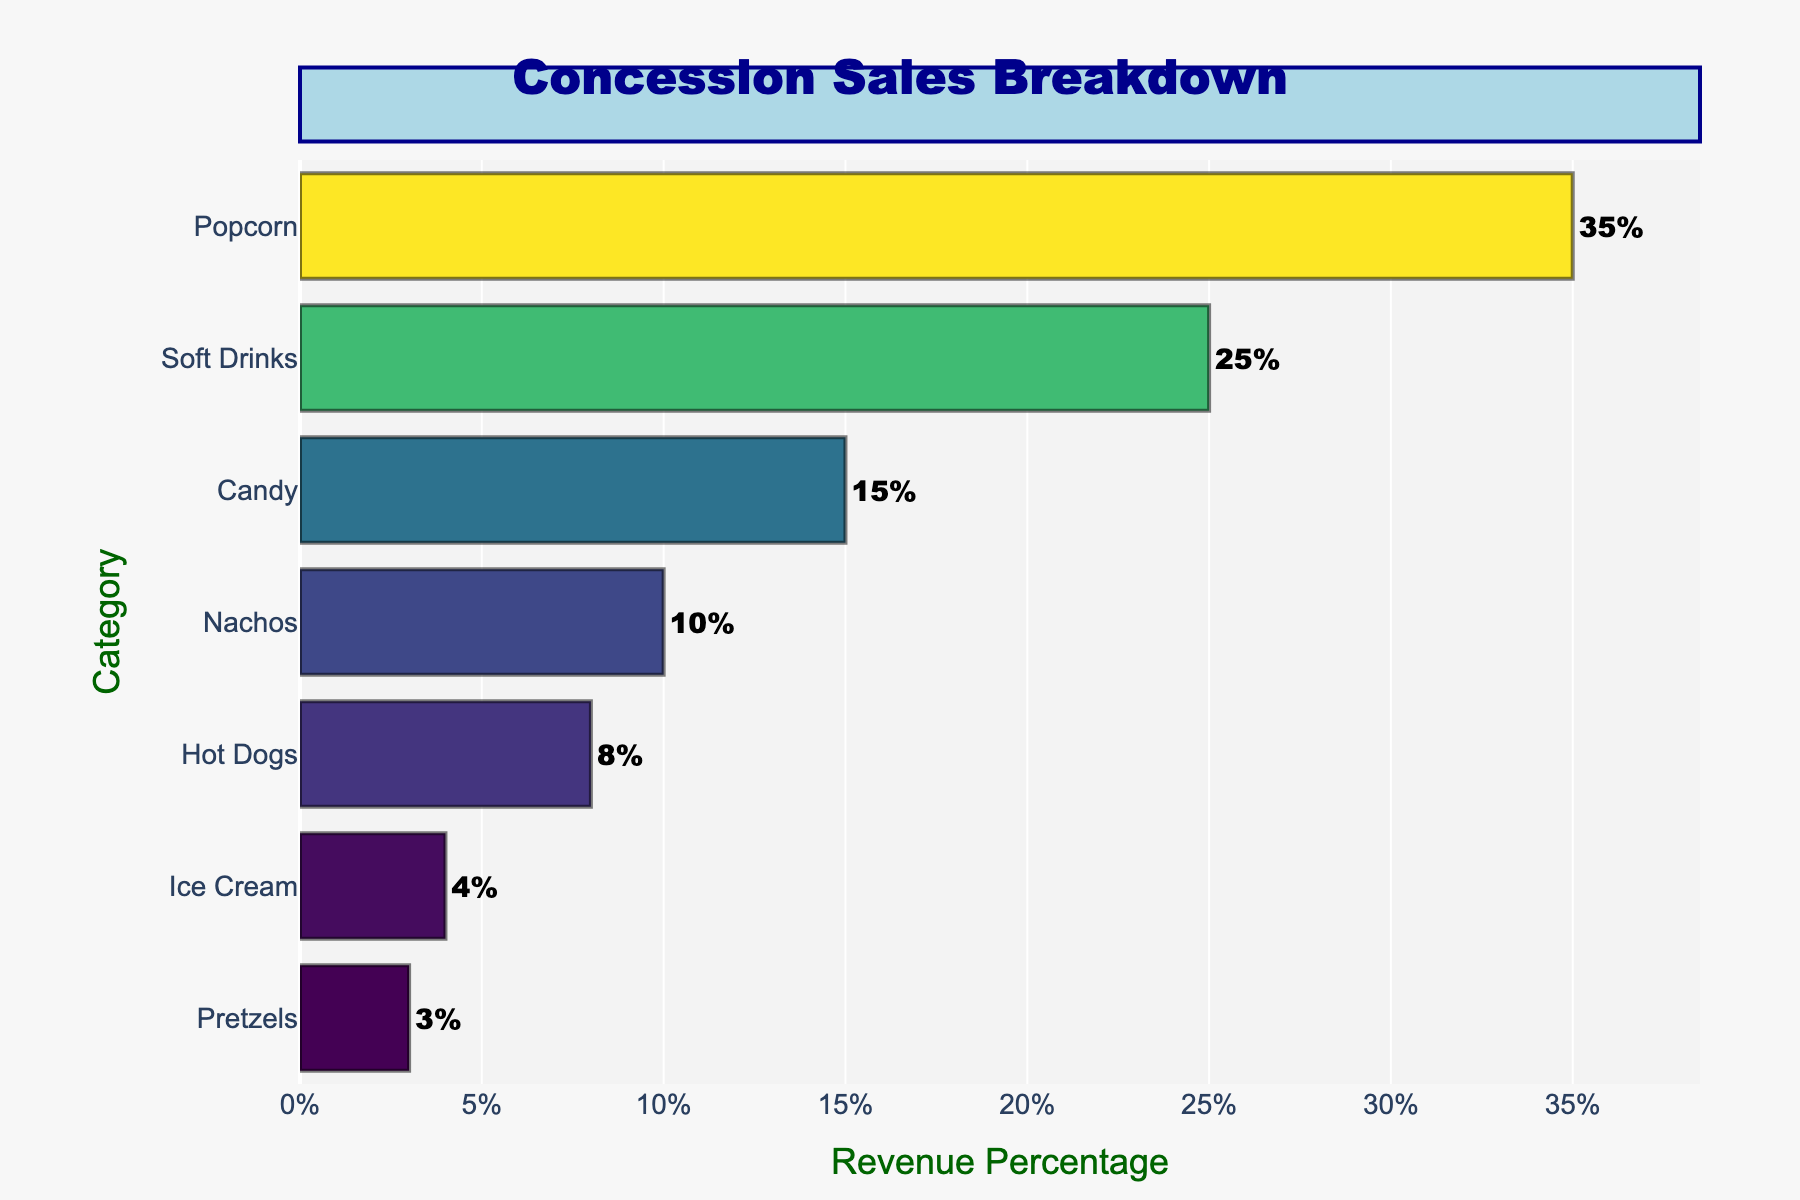What is the highest revenue percentage item in the concession sales breakdown? The horizontal bar chart shows different item categories with their respective revenue percentages. The item with the longest bar is "Popcorn" with a 35% revenue percentage.
Answer: Popcorn Which item category contributes the least to the concession sales revenue? The bar chart displays the categories with their revenue percentages. The shortest bar belongs to "Pretzels," which indicates a 3% revenue percentage.
Answer: Pretzels What is the combined revenue percentage of Soft Drinks and Candy? By looking at the chart, Soft Drinks have a 25% revenue and Candy has 15%. Adding these two percentages together gives the combined revenue percentage. 25% + 15% = 40%
Answer: 40% How much more revenue percentage does Popcorn generate compared to Hot Dogs? The chart shows that Popcorn has a 35% revenue, while Hot Dogs have an 8% revenue. Subtracting the percentage of Hot Dogs from Popcorn gives the difference: 35% - 8% = 27%
Answer: 27% Which item categories have a revenue percentage higher than 10%? Observing the chart, the items with revenue percentages greater than 10% are Popcorn, Soft Drinks, and Candy. Their percentages are 35%, 25%, and 15% respectively.
Answer: Popcorn, Soft Drinks, Candy What is the average revenue percentage of Ice Cream and Pretzels? The revenue percentages for Ice Cream and Pretzels are 4% and 3% respectively. The average is calculated by adding them together and dividing by 2: (4% + 3%) / 2 = 3.5%
Answer: 3.5% Are Nachos or Candy generating more revenue? Comparing the revenue percentages from the chart, Candy has 15% while Nachos have 10%. Candy generates more revenue.
Answer: Candy How does the revenue percentage of Soft Drinks compare to that of Nachos? The revenue percentage of Soft Drinks is 25% and that of Nachos is 10%. Therefore, Soft Drinks have a higher revenue percentage.
Answer: Soft Drinks have a higher revenue percentage What is the total revenue percentage of items generating less than 10% individually? The items with revenue percentages less than 10% are Hot Dogs (8%), Ice Cream (4%), and Pretzels (3%). Adding these percentages gives the total: 8% + 4% + 3% = 15%
Answer: 15% What is the second highest revenue-generating item in the concession sales breakdown? The chart shows that the highest revenue is from Popcorn at 35%. The second highest revenue is from Soft Drinks, which has a revenue percentage of 25%.
Answer: Soft Drinks 